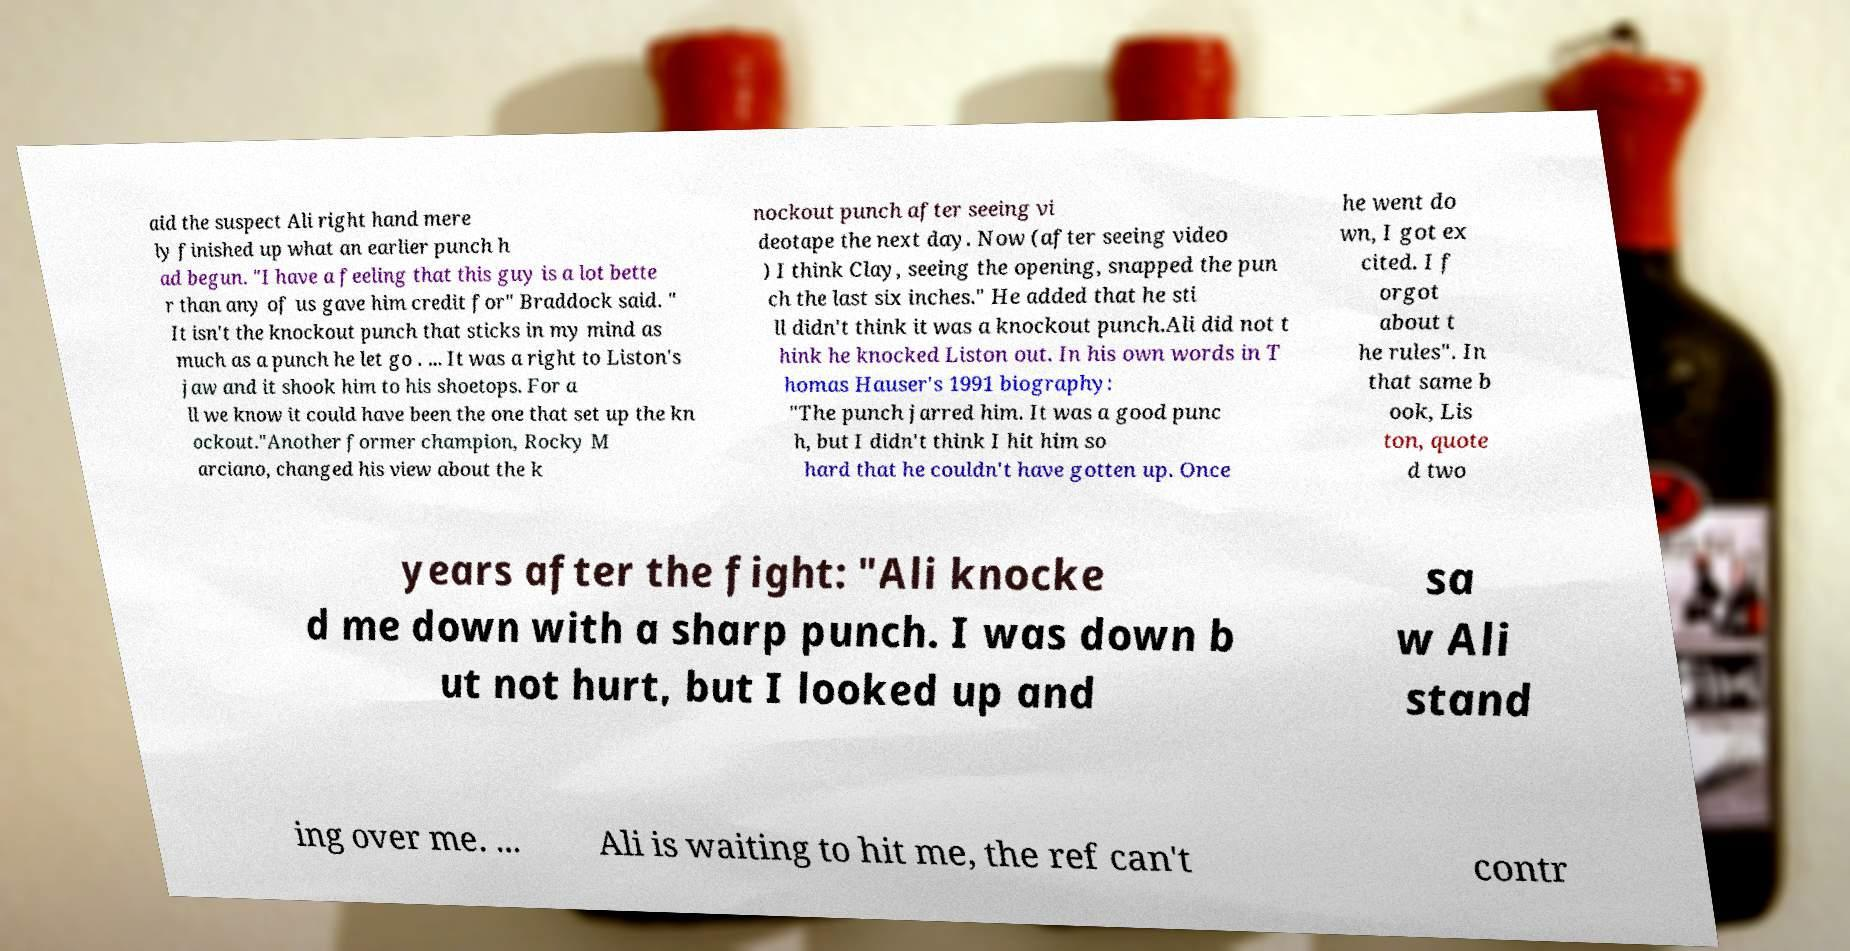What messages or text are displayed in this image? I need them in a readable, typed format. aid the suspect Ali right hand mere ly finished up what an earlier punch h ad begun. "I have a feeling that this guy is a lot bette r than any of us gave him credit for" Braddock said. " It isn't the knockout punch that sticks in my mind as much as a punch he let go . ... It was a right to Liston's jaw and it shook him to his shoetops. For a ll we know it could have been the one that set up the kn ockout."Another former champion, Rocky M arciano, changed his view about the k nockout punch after seeing vi deotape the next day. Now (after seeing video ) I think Clay, seeing the opening, snapped the pun ch the last six inches." He added that he sti ll didn't think it was a knockout punch.Ali did not t hink he knocked Liston out. In his own words in T homas Hauser's 1991 biography: "The punch jarred him. It was a good punc h, but I didn't think I hit him so hard that he couldn't have gotten up. Once he went do wn, I got ex cited. I f orgot about t he rules". In that same b ook, Lis ton, quote d two years after the fight: "Ali knocke d me down with a sharp punch. I was down b ut not hurt, but I looked up and sa w Ali stand ing over me. ... Ali is waiting to hit me, the ref can't contr 